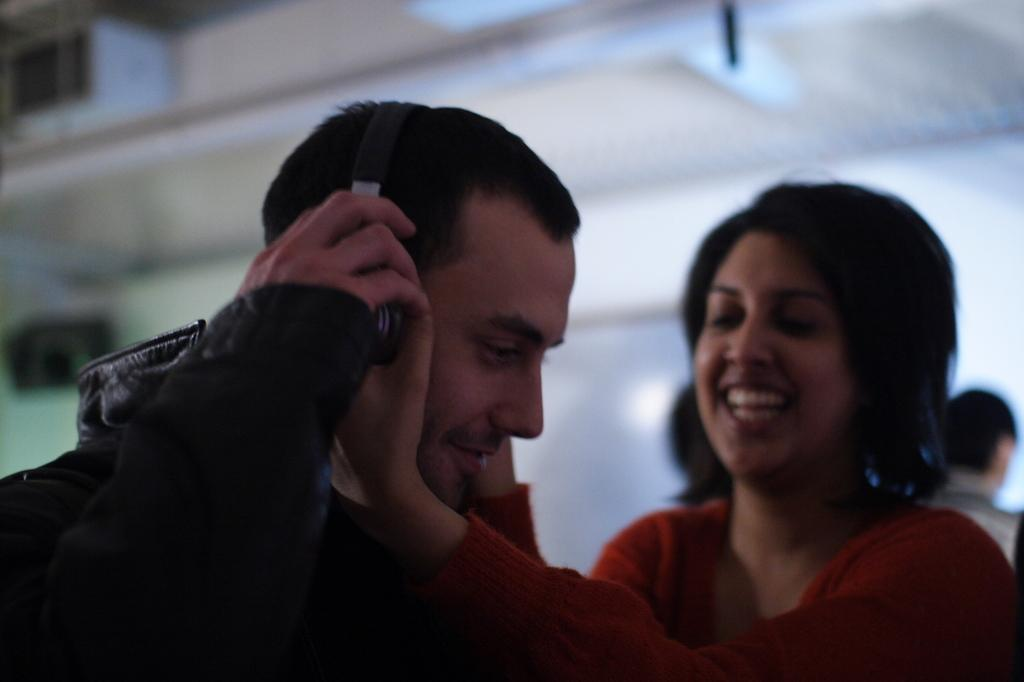How many people are in the main focus of the image? Two persons are standing in the middle of the image. What is the facial expression of the people in the image? The two persons are smiling. Can you identify any accessories worn by one of the persons? One person is wearing a headphone. What can be observed about the background of the image? The background of the image is blurred. Are there any other people visible in the image? Yes, there are people standing in the background. What type of comfort does the brother provide to the achiever in the image? There is no mention of a brother or an achiever in the image, so it is not possible to answer this question. 